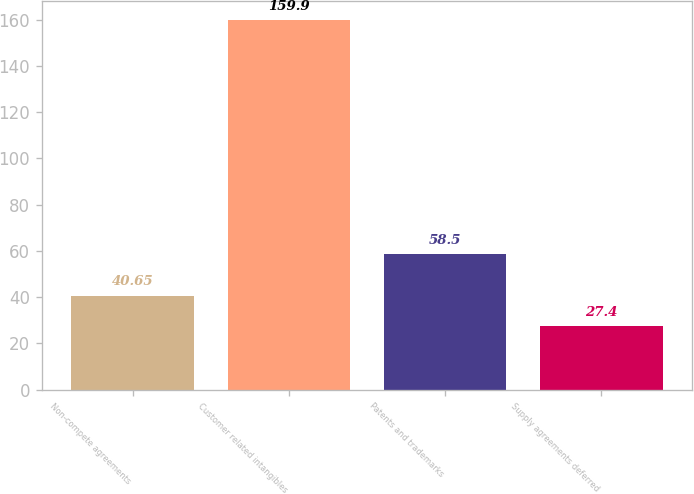Convert chart to OTSL. <chart><loc_0><loc_0><loc_500><loc_500><bar_chart><fcel>Non-compete agreements<fcel>Customer related intangibles<fcel>Patents and trademarks<fcel>Supply agreements deferred<nl><fcel>40.65<fcel>159.9<fcel>58.5<fcel>27.4<nl></chart> 